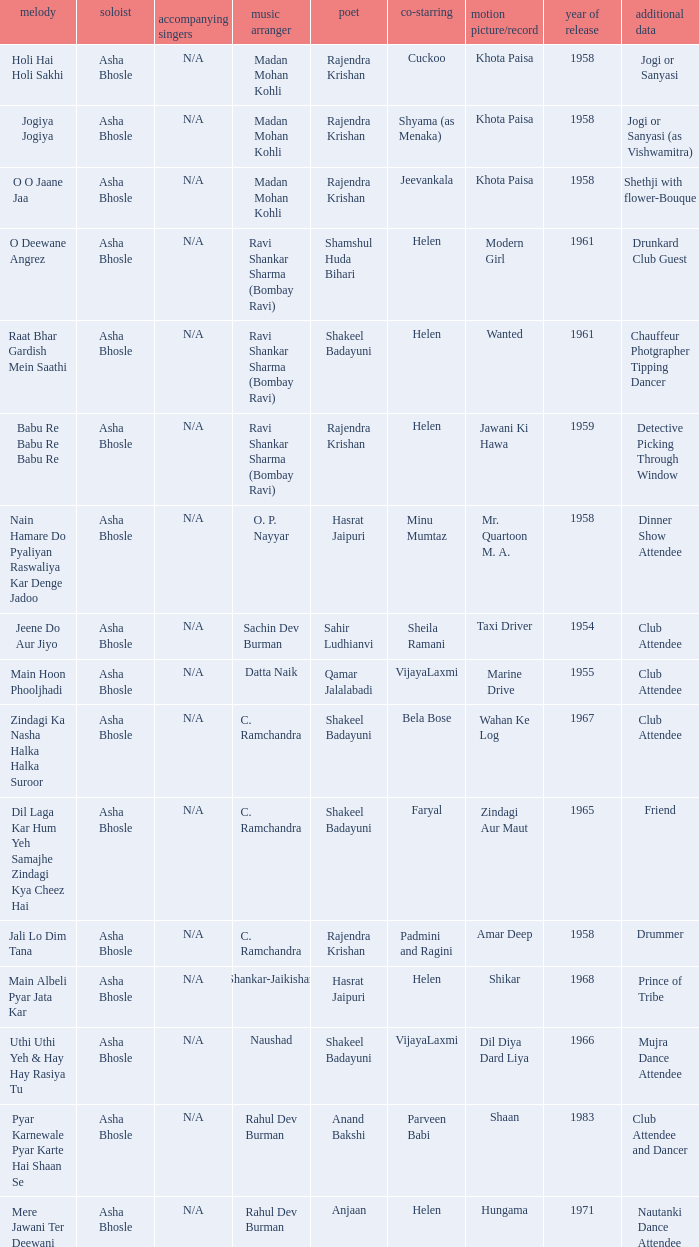Who was the singer in the film amar deep? Asha Bhosle. 